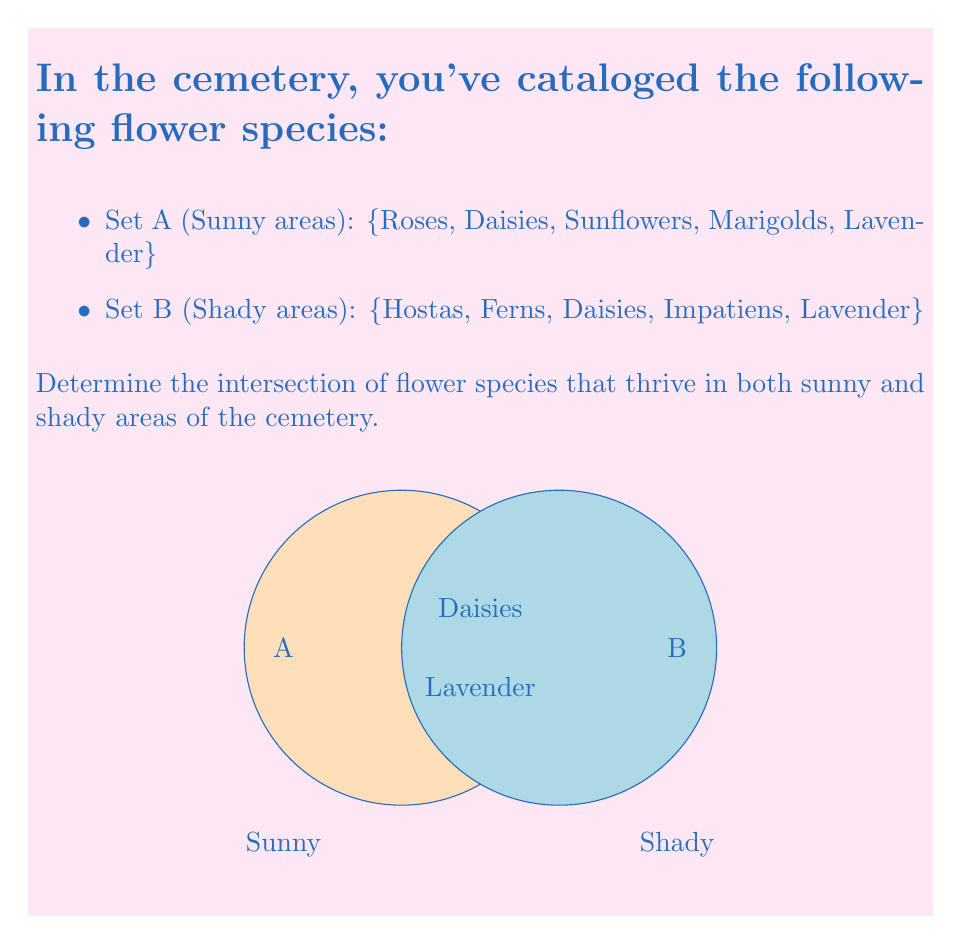Could you help me with this problem? To find the intersection of two sets, we need to identify the elements that are common to both sets. Let's approach this step-by-step:

1) We are given two sets:
   Set A (Sunny areas): $A = \{Roses, Daisies, Sunflowers, Marigolds, Lavender\}$
   Set B (Shady areas): $B = \{Hostas, Ferns, Daisies, Impatiens, Lavender\}$

2) The intersection of sets A and B is denoted as $A \cap B$, which represents all elements that are in both A and B.

3) Let's compare the elements of both sets:
   - Roses: only in A
   - Daisies: in both A and B
   - Sunflowers: only in A
   - Marigolds: only in A
   - Lavender: in both A and B
   - Hostas: only in B
   - Ferns: only in B
   - Impatiens: only in B

4) We can see that Daisies and Lavender are the only elements present in both sets.

5) Therefore, the intersection of A and B is:
   $A \cap B = \{Daisies, Lavender\}$

This means that Daisies and Lavender are the flower species that thrive in both sunny and shady areas of the cemetery.
Answer: $\{Daisies, Lavender\}$ 